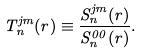Convert formula to latex. <formula><loc_0><loc_0><loc_500><loc_500>T ^ { j m } _ { n } ( r ) \equiv \frac { S _ { n } ^ { j m } ( r ) } { S _ { n } ^ { 0 0 } ( r ) } .</formula> 